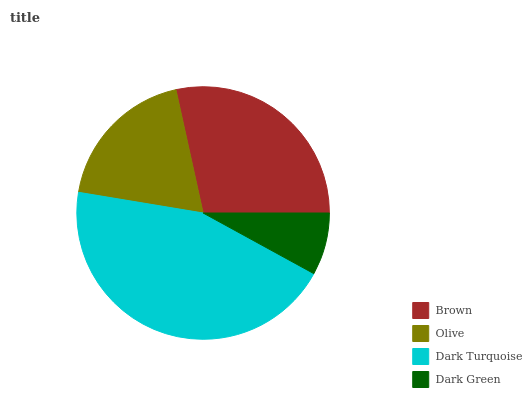Is Dark Green the minimum?
Answer yes or no. Yes. Is Dark Turquoise the maximum?
Answer yes or no. Yes. Is Olive the minimum?
Answer yes or no. No. Is Olive the maximum?
Answer yes or no. No. Is Brown greater than Olive?
Answer yes or no. Yes. Is Olive less than Brown?
Answer yes or no. Yes. Is Olive greater than Brown?
Answer yes or no. No. Is Brown less than Olive?
Answer yes or no. No. Is Brown the high median?
Answer yes or no. Yes. Is Olive the low median?
Answer yes or no. Yes. Is Olive the high median?
Answer yes or no. No. Is Brown the low median?
Answer yes or no. No. 